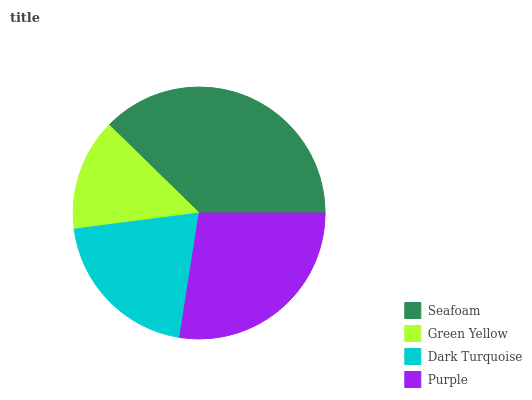Is Green Yellow the minimum?
Answer yes or no. Yes. Is Seafoam the maximum?
Answer yes or no. Yes. Is Dark Turquoise the minimum?
Answer yes or no. No. Is Dark Turquoise the maximum?
Answer yes or no. No. Is Dark Turquoise greater than Green Yellow?
Answer yes or no. Yes. Is Green Yellow less than Dark Turquoise?
Answer yes or no. Yes. Is Green Yellow greater than Dark Turquoise?
Answer yes or no. No. Is Dark Turquoise less than Green Yellow?
Answer yes or no. No. Is Purple the high median?
Answer yes or no. Yes. Is Dark Turquoise the low median?
Answer yes or no. Yes. Is Seafoam the high median?
Answer yes or no. No. Is Green Yellow the low median?
Answer yes or no. No. 